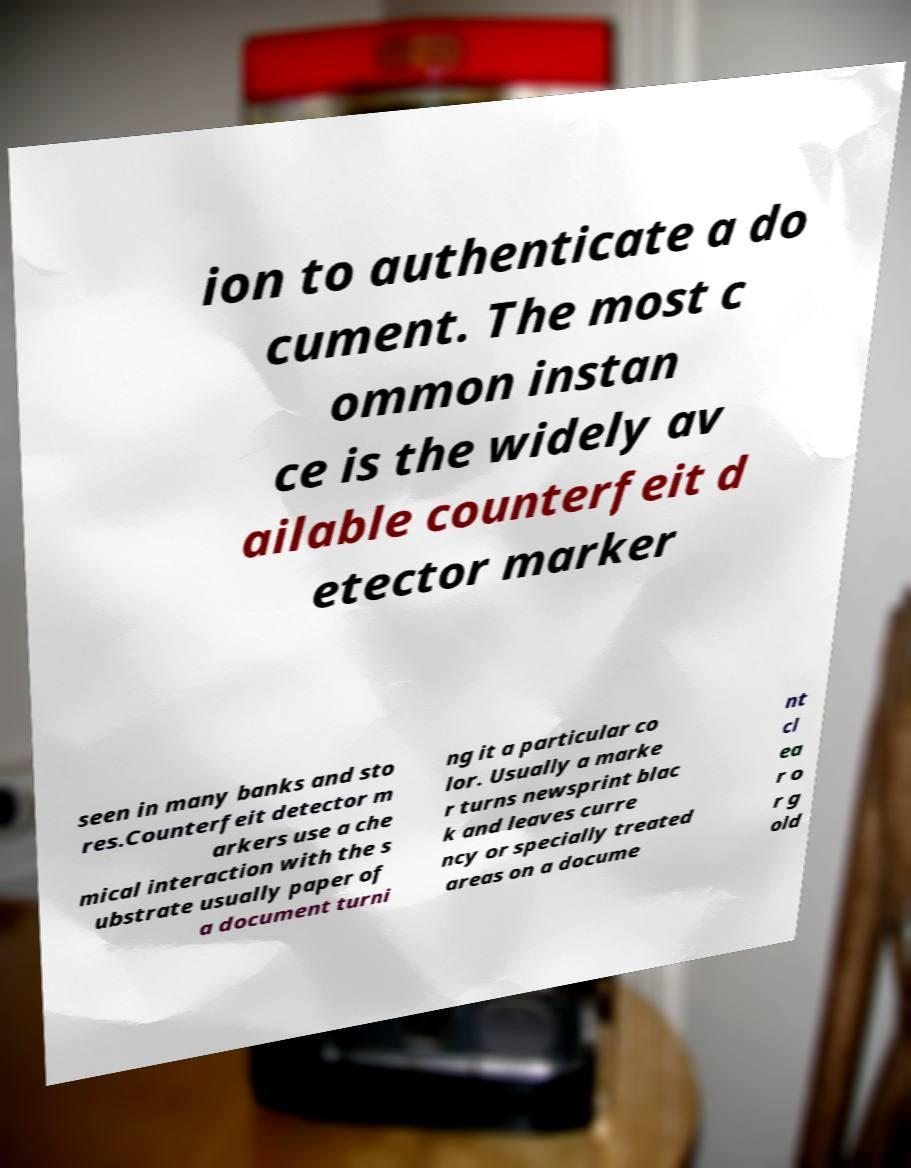I need the written content from this picture converted into text. Can you do that? ion to authenticate a do cument. The most c ommon instan ce is the widely av ailable counterfeit d etector marker seen in many banks and sto res.Counterfeit detector m arkers use a che mical interaction with the s ubstrate usually paper of a document turni ng it a particular co lor. Usually a marke r turns newsprint blac k and leaves curre ncy or specially treated areas on a docume nt cl ea r o r g old 